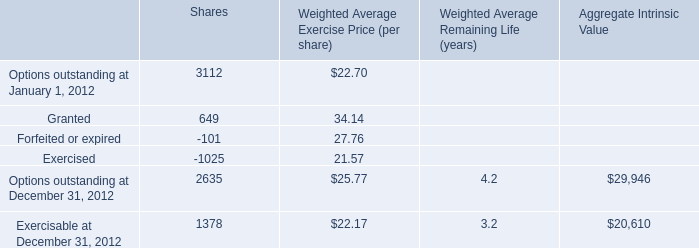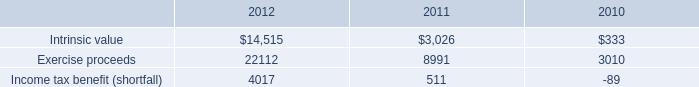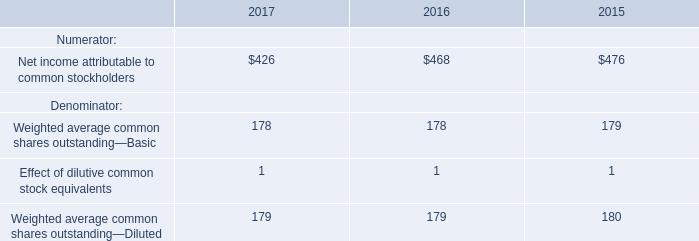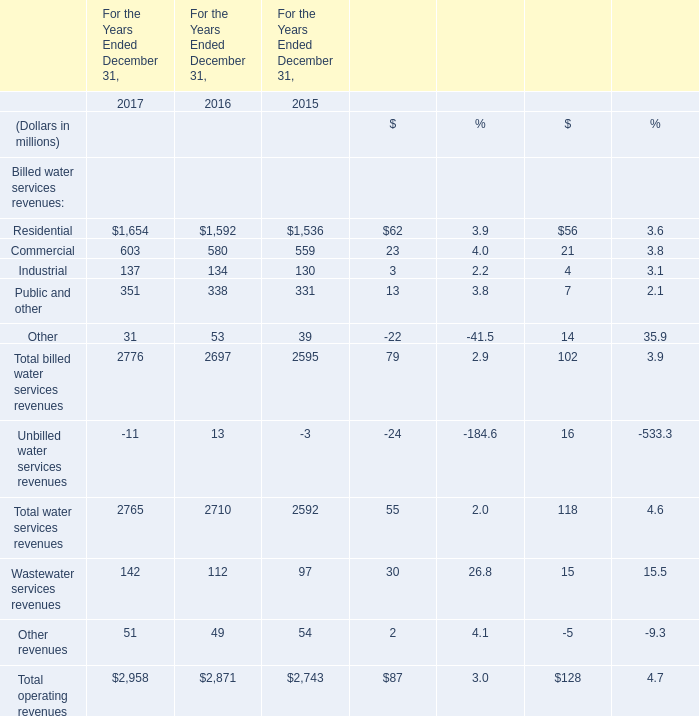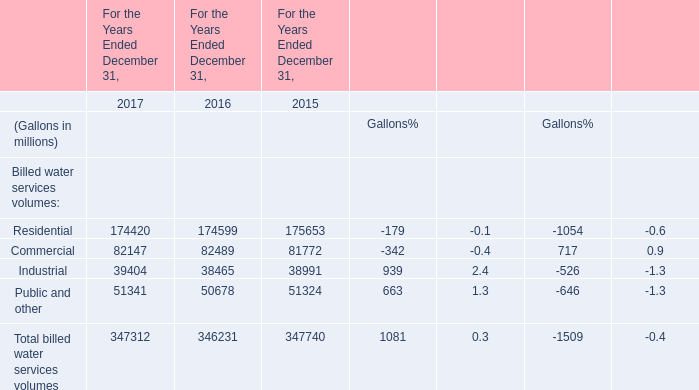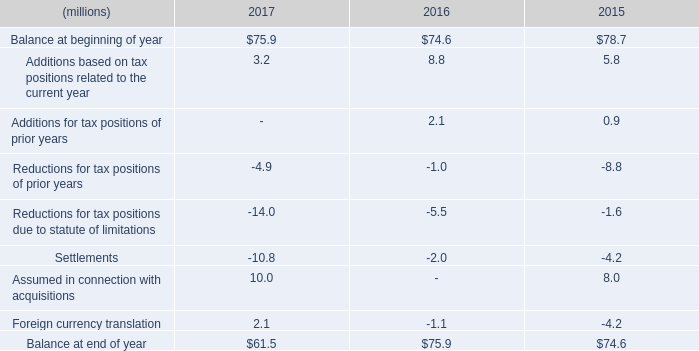what is the percentage change in the balance of gross liability for unrecognized tax benefits from 2016 to 2017? 
Computations: ((61.5 - 75.9) / 75.9)
Answer: -0.18972. 